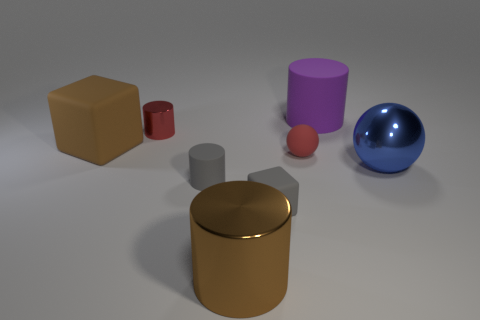There is a cylinder that is the same color as the large matte cube; what material is it?
Your answer should be compact. Metal. Is the big cylinder that is on the left side of the small cube made of the same material as the object that is to the right of the purple cylinder?
Make the answer very short. Yes. Are there more large matte cylinders than tiny red things?
Ensure brevity in your answer.  No. What is the color of the block behind the matte thing that is in front of the gray cylinder to the left of the big brown metal cylinder?
Your answer should be very brief. Brown. Is the color of the matte cylinder that is in front of the large purple cylinder the same as the cube to the right of the red metallic cylinder?
Ensure brevity in your answer.  Yes. What number of red things are to the left of the metal cylinder that is left of the gray cylinder?
Your response must be concise. 0. Are there any large yellow metal cylinders?
Make the answer very short. No. How many other things are the same color as the big shiny sphere?
Your answer should be very brief. 0. Are there fewer big brown metallic cylinders than big cyan cubes?
Ensure brevity in your answer.  No. There is a tiny red object that is in front of the matte block to the left of the small gray cylinder; what is its shape?
Your response must be concise. Sphere. 